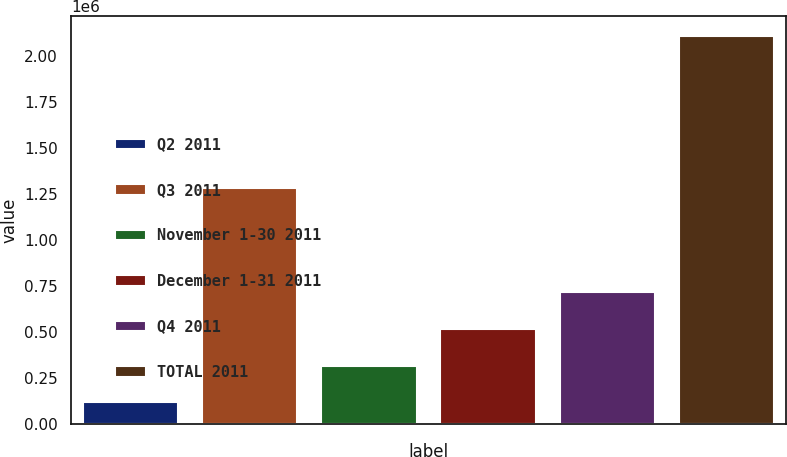Convert chart. <chart><loc_0><loc_0><loc_500><loc_500><bar_chart><fcel>Q2 2011<fcel>Q3 2011<fcel>November 1-30 2011<fcel>December 1-31 2011<fcel>Q4 2011<fcel>TOTAL 2011<nl><fcel>118578<fcel>1.28281e+06<fcel>317536<fcel>516494<fcel>715452<fcel>2.10816e+06<nl></chart> 